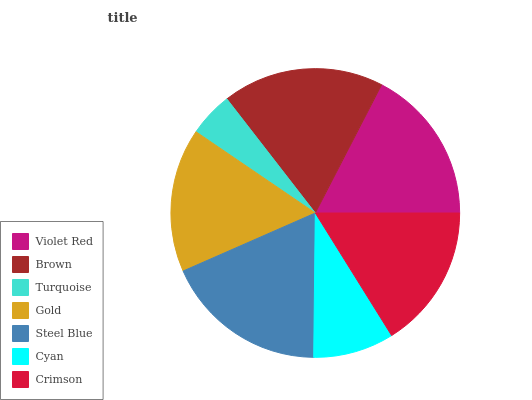Is Turquoise the minimum?
Answer yes or no. Yes. Is Steel Blue the maximum?
Answer yes or no. Yes. Is Brown the minimum?
Answer yes or no. No. Is Brown the maximum?
Answer yes or no. No. Is Brown greater than Violet Red?
Answer yes or no. Yes. Is Violet Red less than Brown?
Answer yes or no. Yes. Is Violet Red greater than Brown?
Answer yes or no. No. Is Brown less than Violet Red?
Answer yes or no. No. Is Crimson the high median?
Answer yes or no. Yes. Is Crimson the low median?
Answer yes or no. Yes. Is Brown the high median?
Answer yes or no. No. Is Steel Blue the low median?
Answer yes or no. No. 